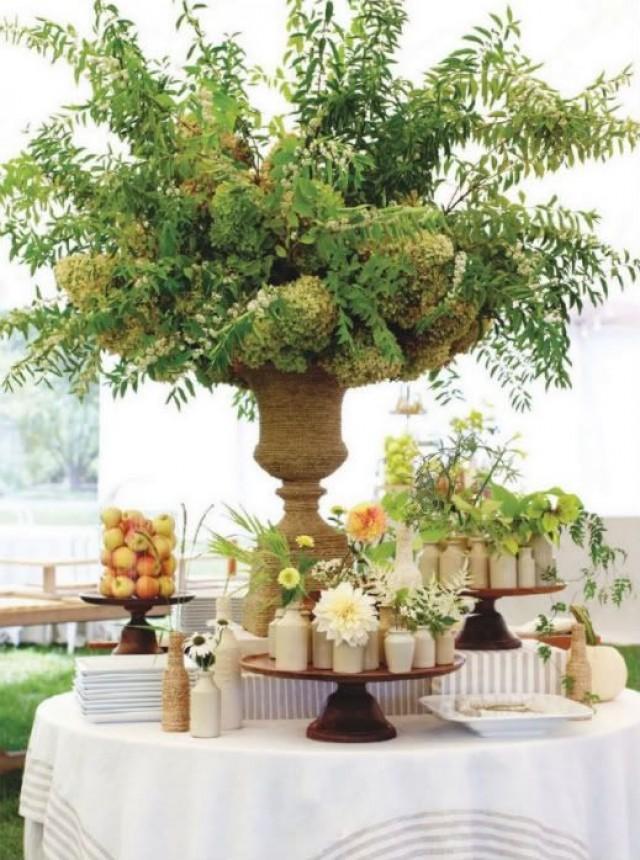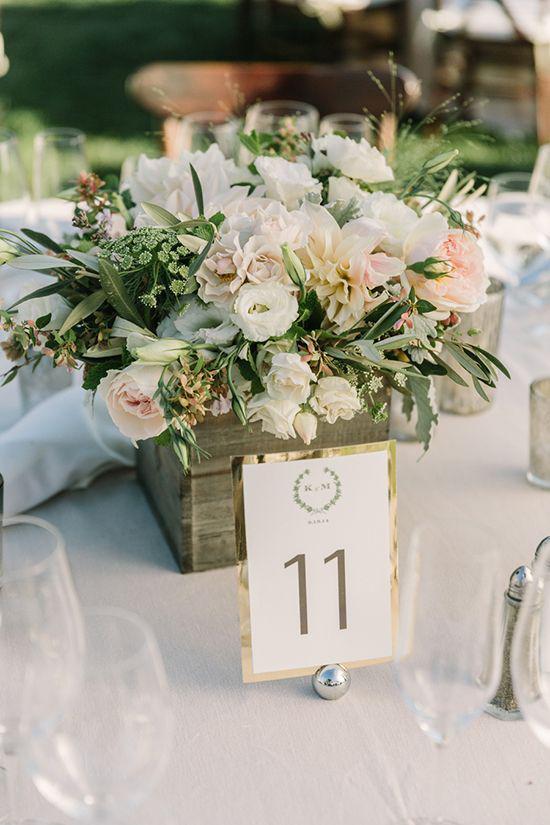The first image is the image on the left, the second image is the image on the right. Evaluate the accuracy of this statement regarding the images: "A plant with no flowers in a tall vase is used as a centerpiece on the table.". Is it true? Answer yes or no. Yes. The first image is the image on the left, the second image is the image on the right. Considering the images on both sides, is "A single numbered label is on top of a decorated table." valid? Answer yes or no. Yes. 